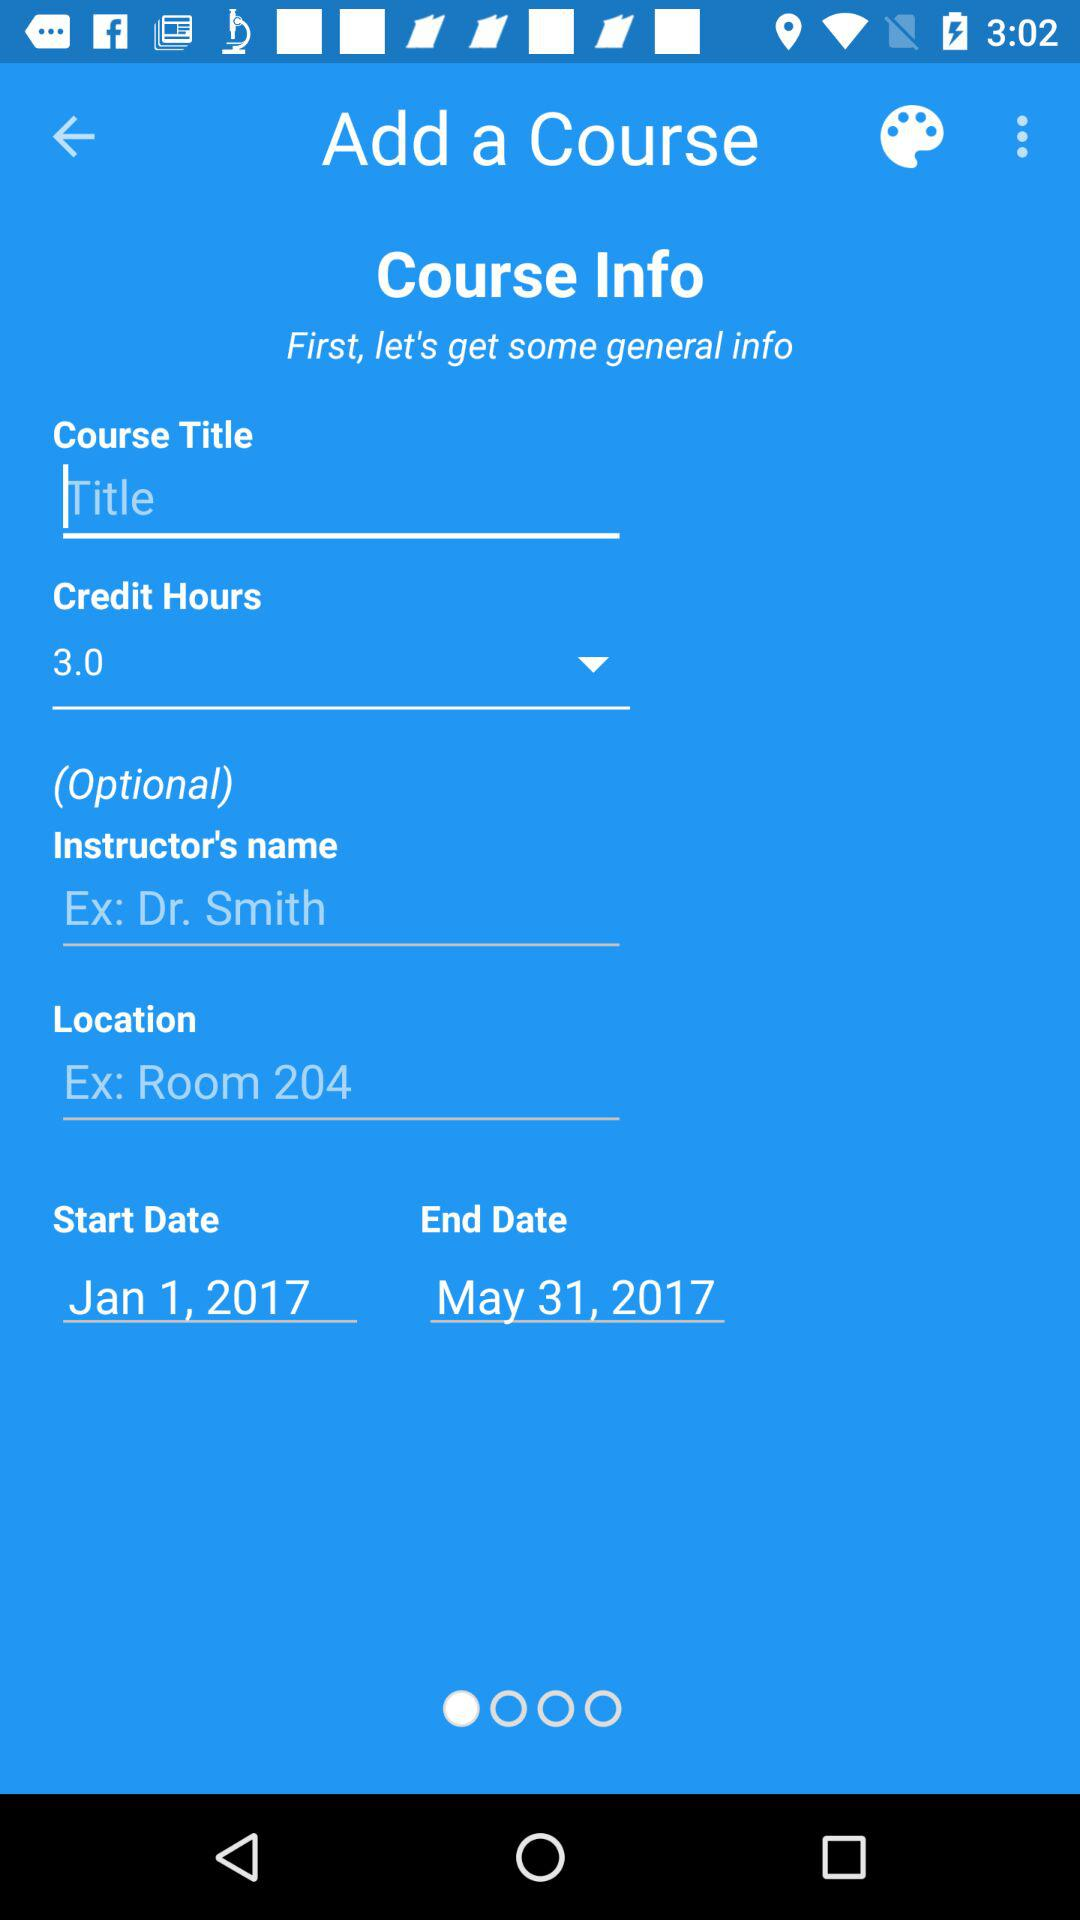What are the credit hours? The credit hours are 3. 